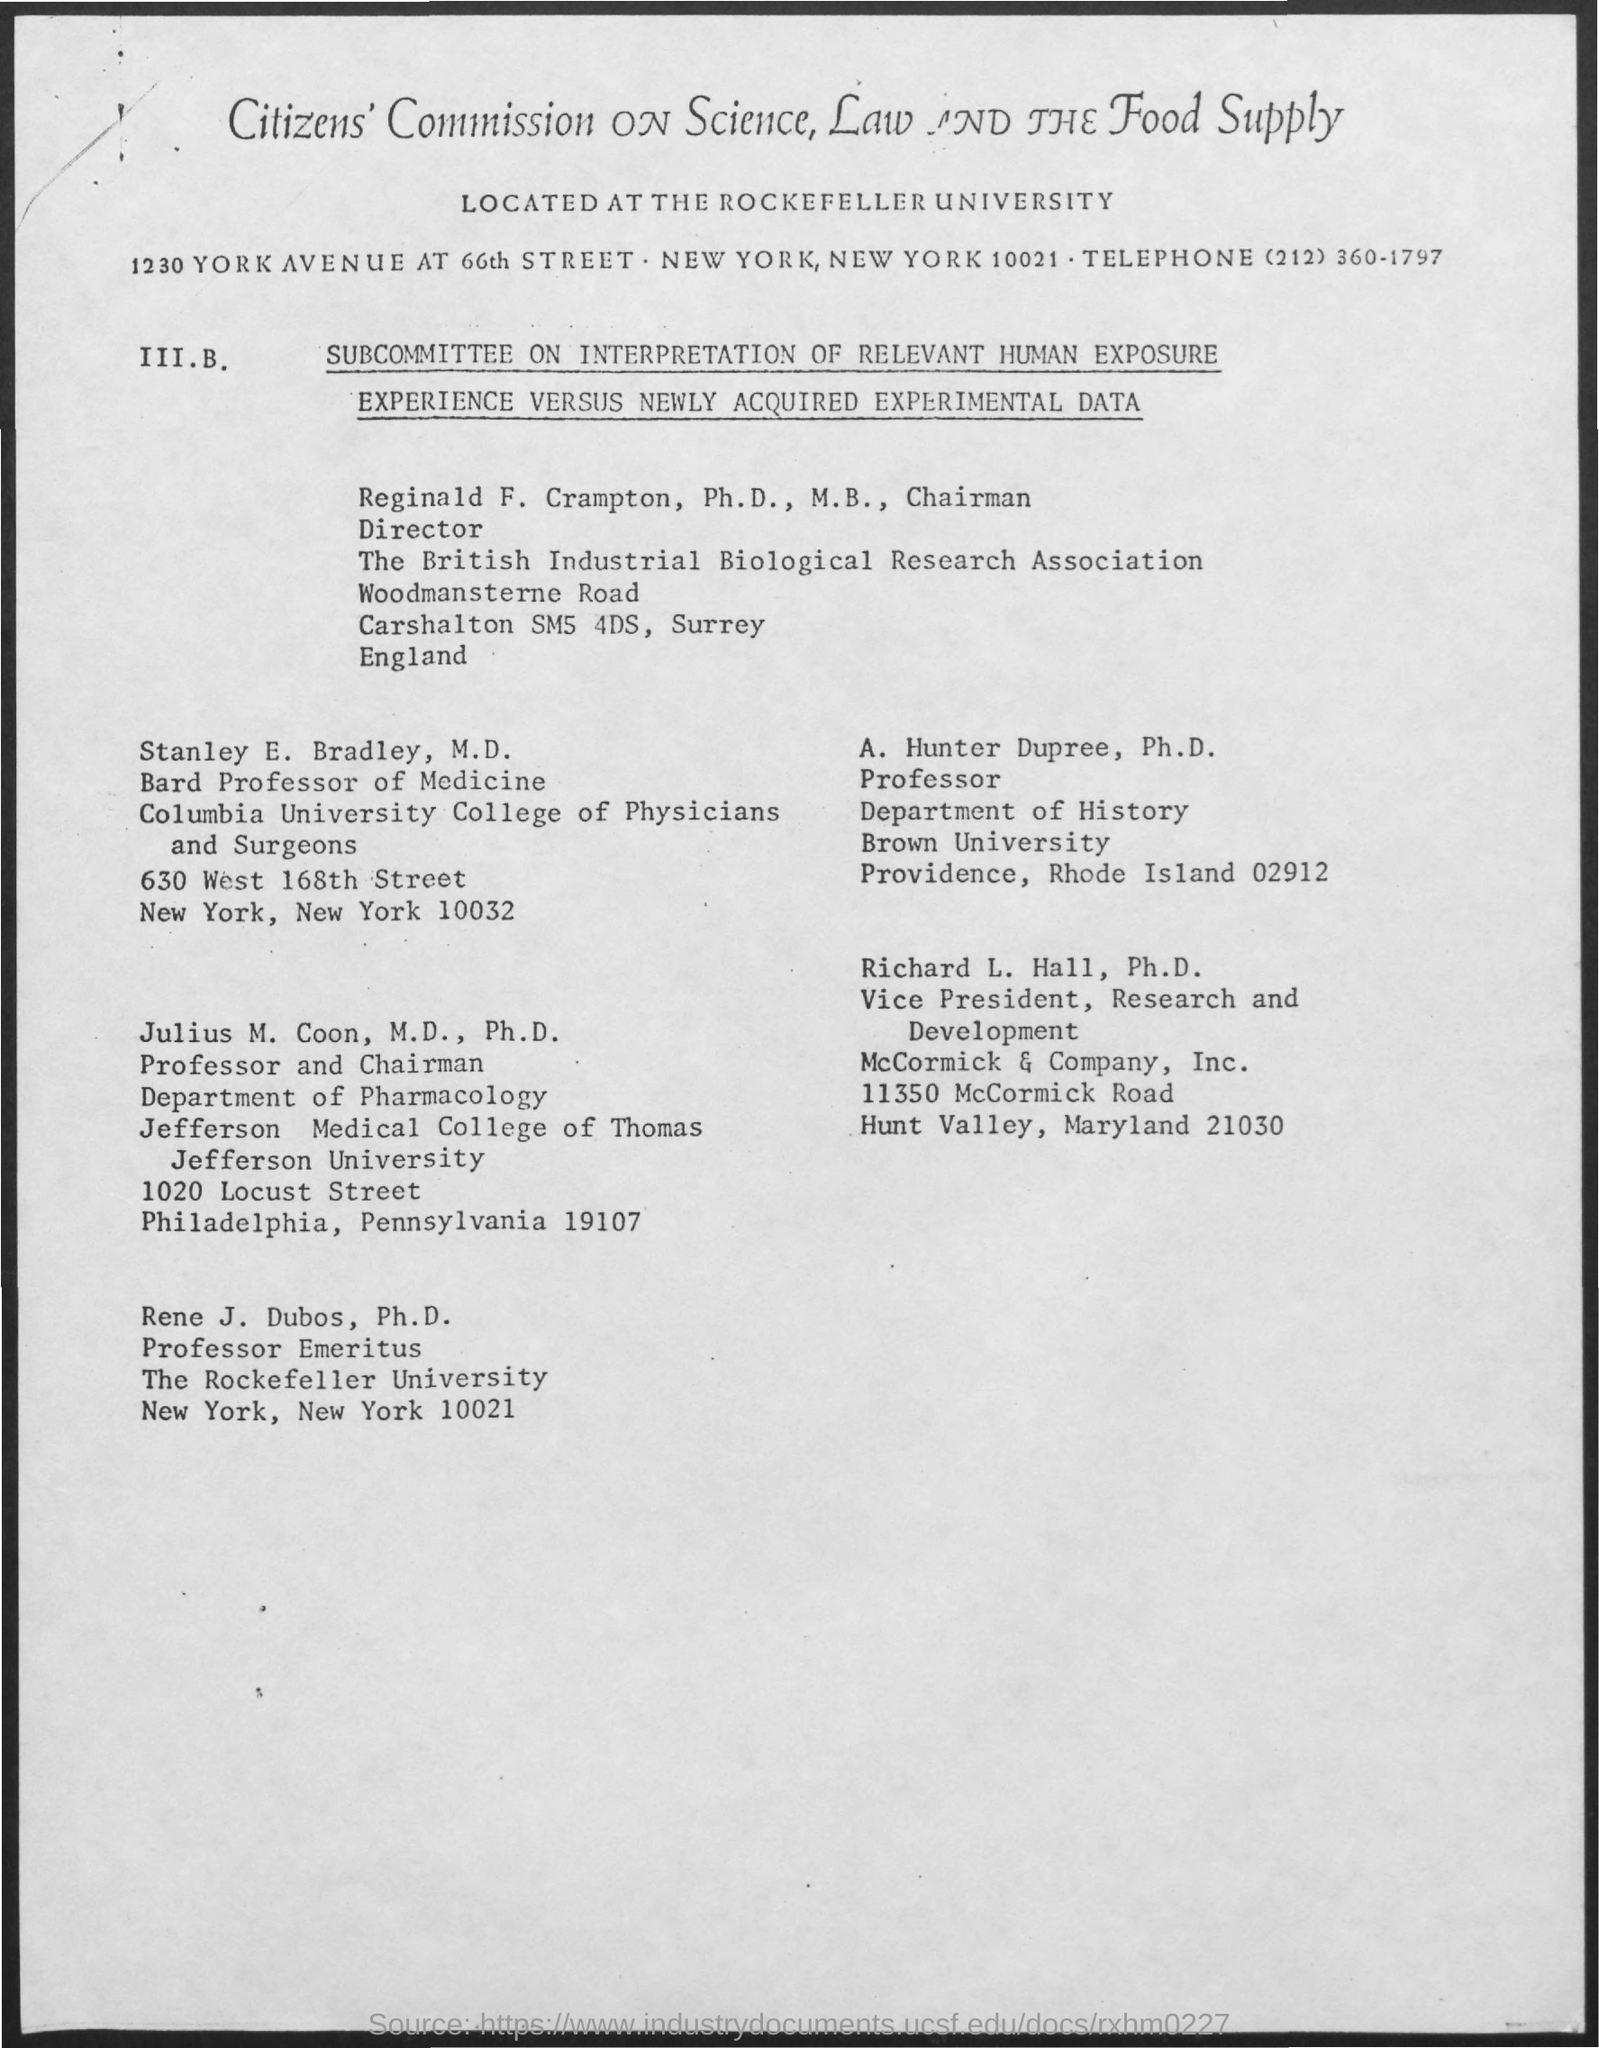Who is the Vice President of Research and Development?
Make the answer very short. Richard L. Hall, Ph.D. Who is the Professor of the Department of History at Brown University?
Offer a very short reply. A. Hunter Dupree. 